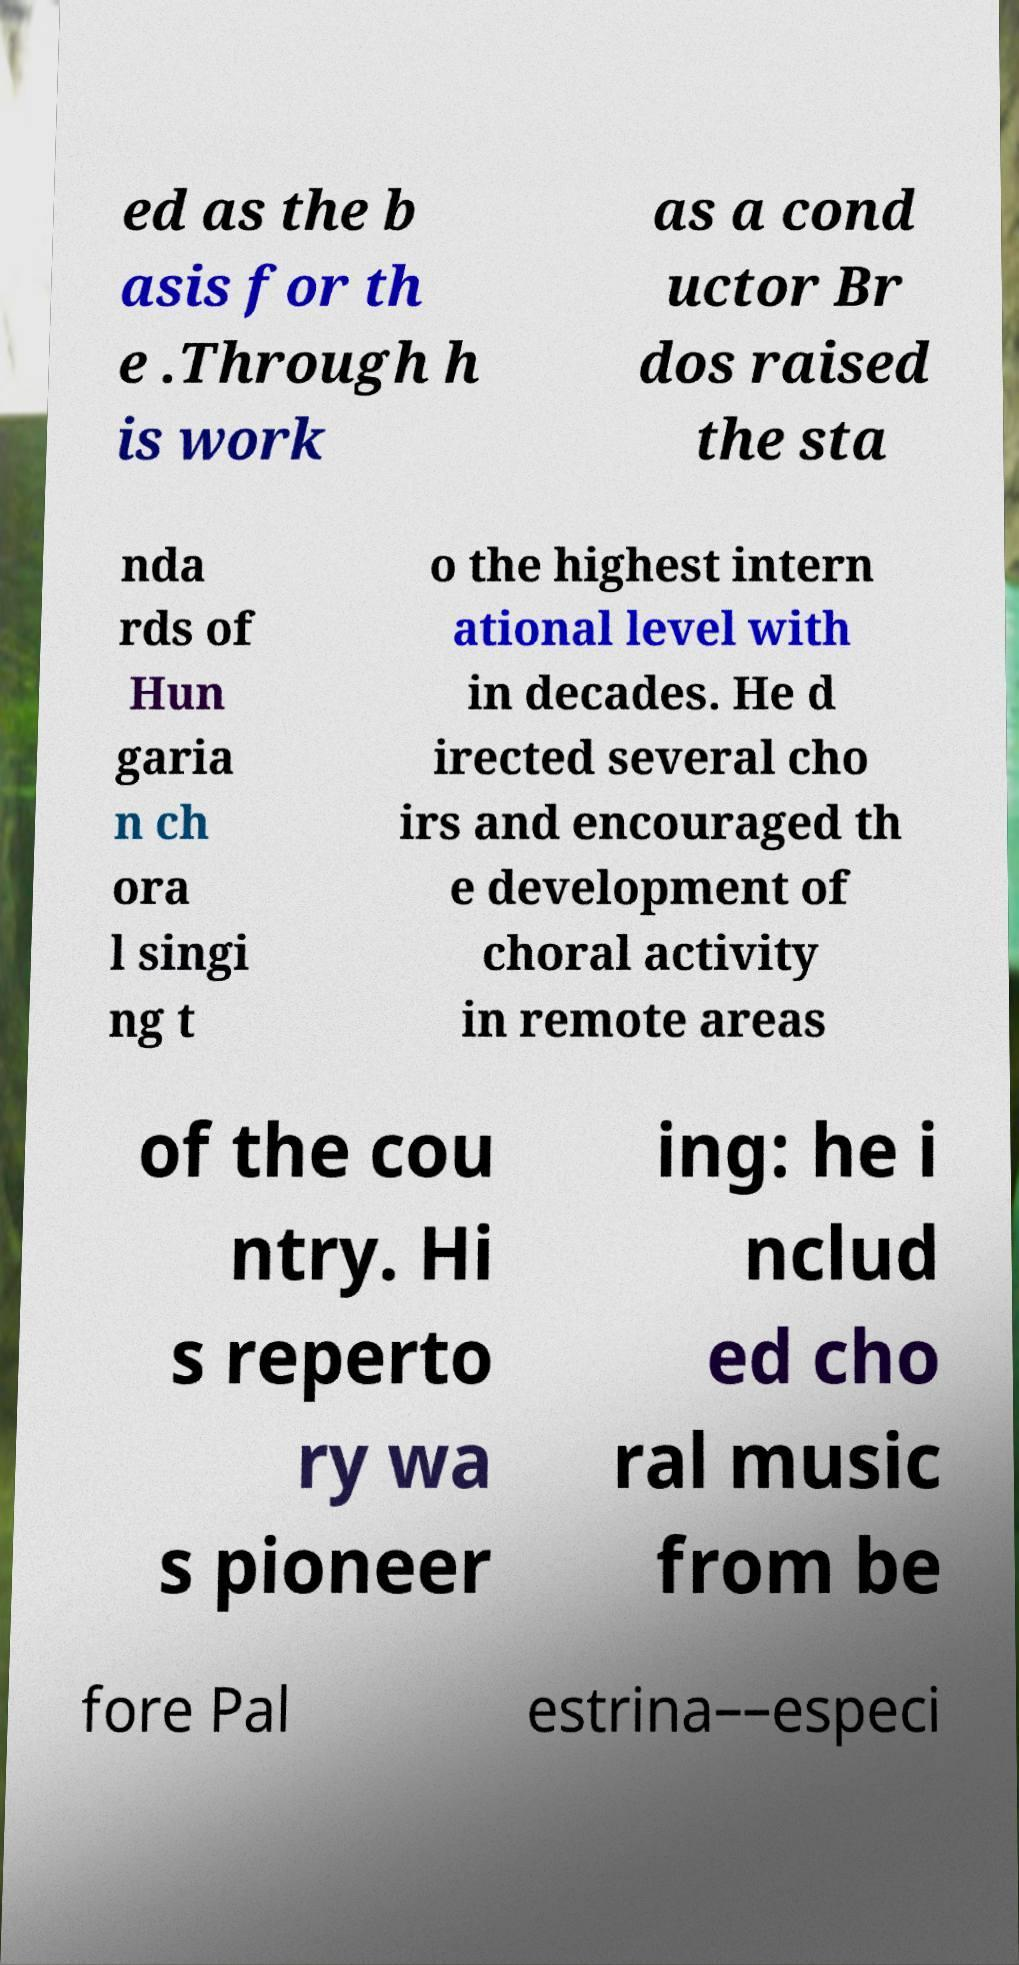I need the written content from this picture converted into text. Can you do that? ed as the b asis for th e .Through h is work as a cond uctor Br dos raised the sta nda rds of Hun garia n ch ora l singi ng t o the highest intern ational level with in decades. He d irected several cho irs and encouraged th e development of choral activity in remote areas of the cou ntry. Hi s reperto ry wa s pioneer ing: he i nclud ed cho ral music from be fore Pal estrina––especi 